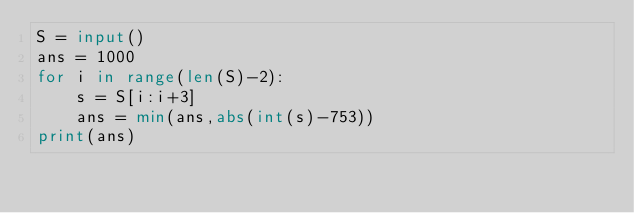<code> <loc_0><loc_0><loc_500><loc_500><_Python_>S = input()
ans = 1000
for i in range(len(S)-2):
    s = S[i:i+3]
    ans = min(ans,abs(int(s)-753))
print(ans)</code> 